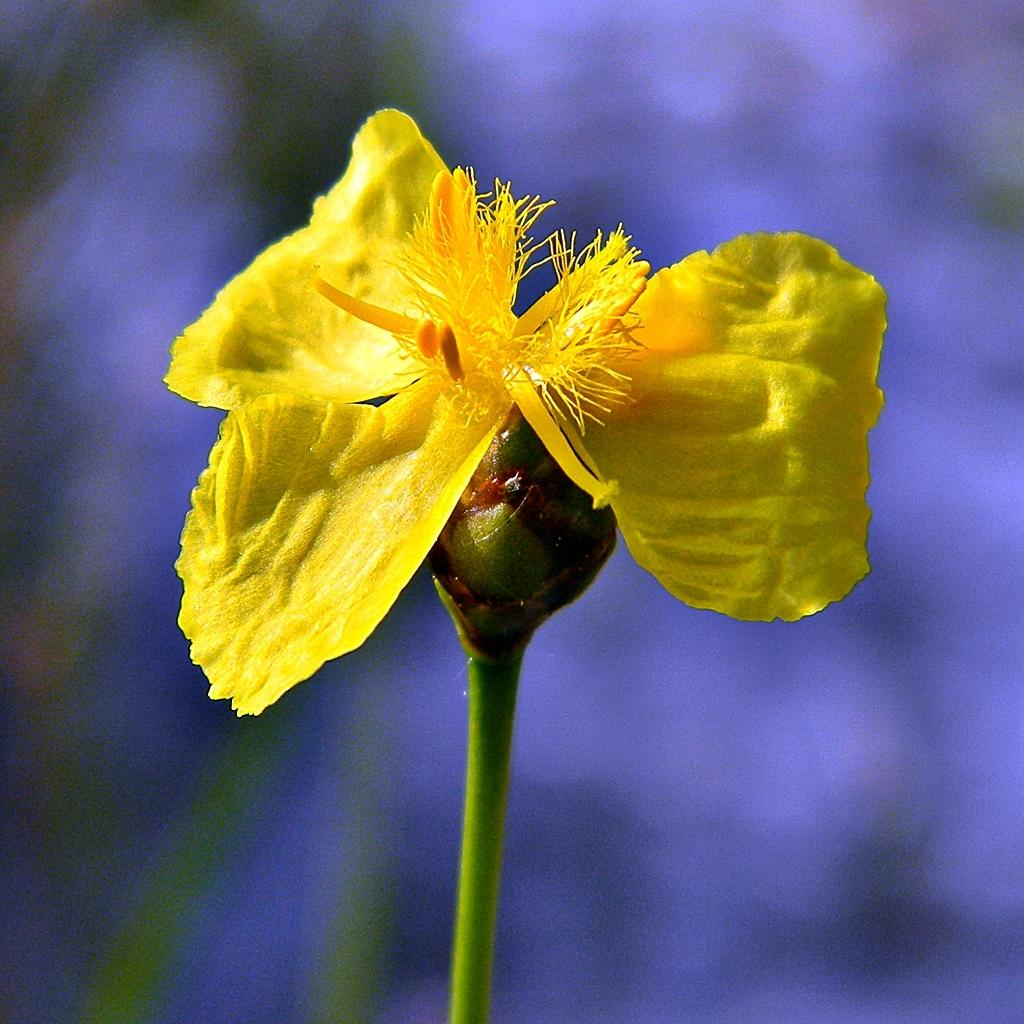What type of flower is present in the image? There is a yellow color flower in the image. Can you describe the background of the image? The background of the image is blurred. What type of badge is visible on the flower in the image? There is no badge present on the flower in the image. What type of business might be associated with the flower in the image? There is no indication of any business association with the flower in the image. 